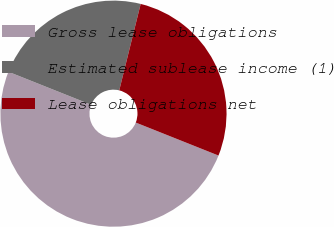Convert chart. <chart><loc_0><loc_0><loc_500><loc_500><pie_chart><fcel>Gross lease obligations<fcel>Estimated sublease income (1)<fcel>Lease obligations net<nl><fcel>50.0%<fcel>22.83%<fcel>27.17%<nl></chart> 